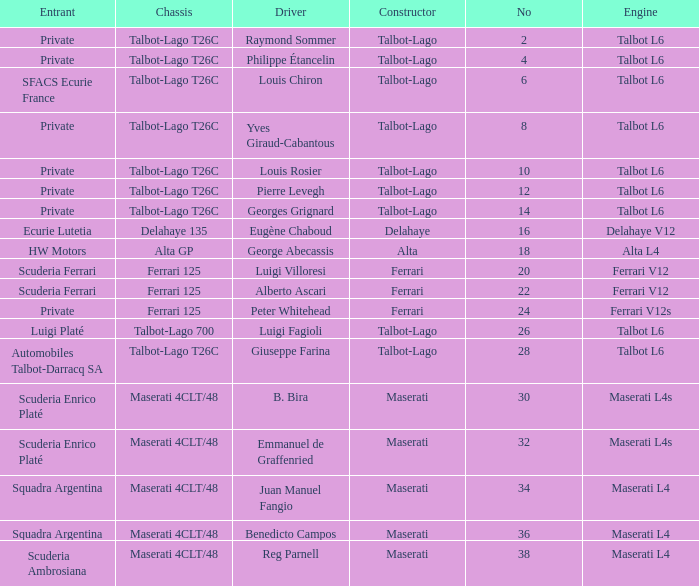Name the constructor for number 10 Talbot-Lago. 